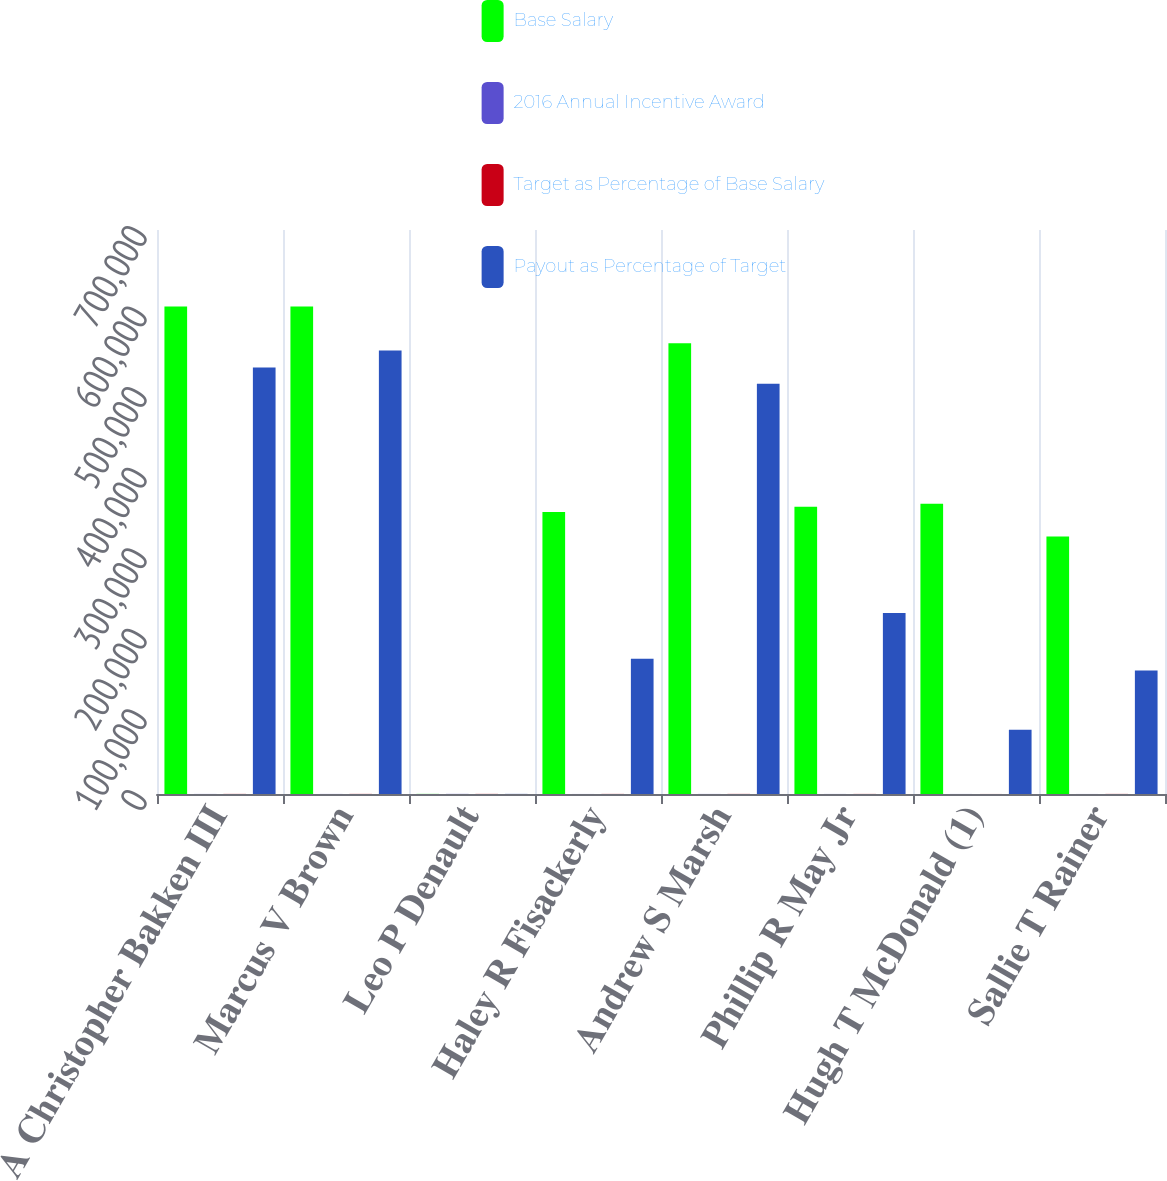Convert chart. <chart><loc_0><loc_0><loc_500><loc_500><stacked_bar_chart><ecel><fcel>A Christopher Bakken III<fcel>Marcus V Brown<fcel>Leo P Denault<fcel>Haley R Fisackerly<fcel>Andrew S Marsh<fcel>Phillip R May Jr<fcel>Hugh T McDonald (1)<fcel>Sallie T Rainer<nl><fcel>Base Salary<fcel>605000<fcel>605000<fcel>134<fcel>350000<fcel>559408<fcel>356650<fcel>360121<fcel>319475<nl><fcel>2016 Annual Incentive Award<fcel>70<fcel>70<fcel>135<fcel>40<fcel>70<fcel>60<fcel>50<fcel>40<nl><fcel>Target as Percentage of Base Salary<fcel>125<fcel>130<fcel>133<fcel>120<fcel>130<fcel>105<fcel>44<fcel>120<nl><fcel>Payout as Percentage of Target<fcel>529375<fcel>550550<fcel>134<fcel>168000<fcel>509061<fcel>224690<fcel>79827<fcel>153348<nl></chart> 